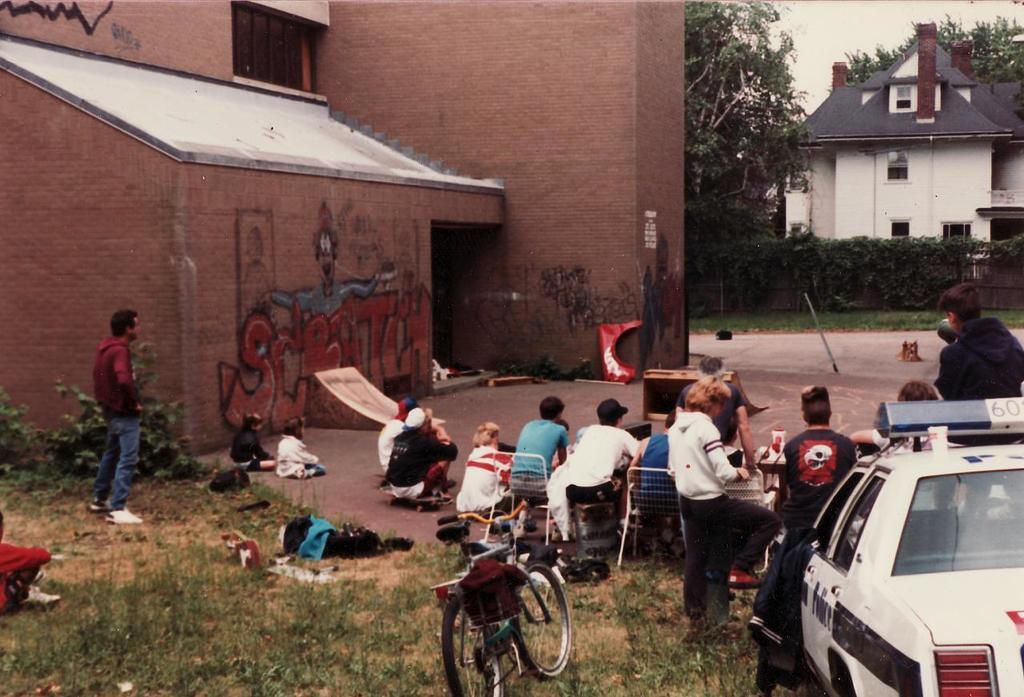Please provide a concise description of this image. In this picture we can see a car, bicycle, grass, chairs, buildings with windows, trees and a group of people where some are sitting and some are standing. 